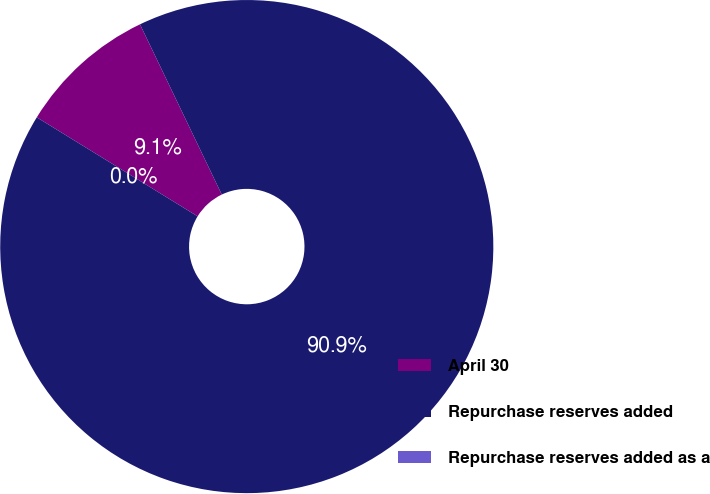<chart> <loc_0><loc_0><loc_500><loc_500><pie_chart><fcel>April 30<fcel>Repurchase reserves added<fcel>Repurchase reserves added as a<nl><fcel>9.09%<fcel>90.91%<fcel>0.0%<nl></chart> 